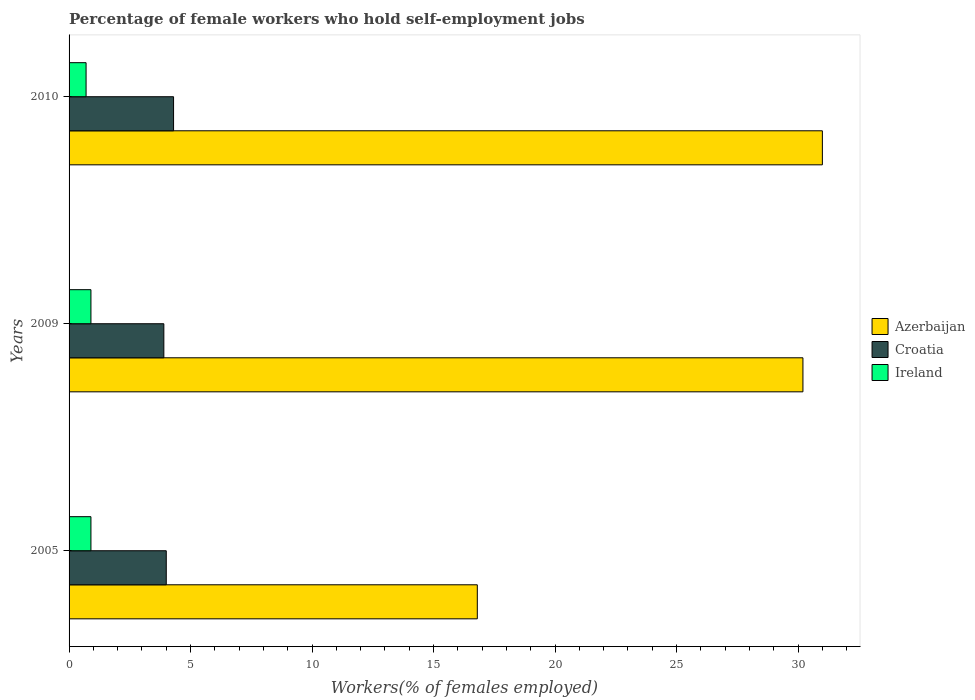How many bars are there on the 1st tick from the top?
Ensure brevity in your answer.  3. How many bars are there on the 3rd tick from the bottom?
Offer a terse response. 3. What is the label of the 1st group of bars from the top?
Give a very brief answer. 2010. What is the percentage of self-employed female workers in Azerbaijan in 2010?
Your answer should be compact. 31. Across all years, what is the maximum percentage of self-employed female workers in Croatia?
Your answer should be very brief. 4.3. Across all years, what is the minimum percentage of self-employed female workers in Croatia?
Offer a terse response. 3.9. In which year was the percentage of self-employed female workers in Ireland minimum?
Your answer should be very brief. 2010. What is the total percentage of self-employed female workers in Ireland in the graph?
Provide a succinct answer. 2.5. What is the difference between the percentage of self-employed female workers in Croatia in 2005 and that in 2009?
Your answer should be compact. 0.1. What is the difference between the percentage of self-employed female workers in Croatia in 2010 and the percentage of self-employed female workers in Ireland in 2009?
Ensure brevity in your answer.  3.4. What is the average percentage of self-employed female workers in Azerbaijan per year?
Provide a succinct answer. 26. In the year 2010, what is the difference between the percentage of self-employed female workers in Croatia and percentage of self-employed female workers in Azerbaijan?
Offer a terse response. -26.7. In how many years, is the percentage of self-employed female workers in Ireland greater than 26 %?
Make the answer very short. 0. What is the ratio of the percentage of self-employed female workers in Azerbaijan in 2009 to that in 2010?
Offer a very short reply. 0.97. Is the percentage of self-employed female workers in Azerbaijan in 2005 less than that in 2010?
Offer a terse response. Yes. What is the difference between the highest and the second highest percentage of self-employed female workers in Ireland?
Offer a very short reply. 0. What is the difference between the highest and the lowest percentage of self-employed female workers in Ireland?
Keep it short and to the point. 0.2. In how many years, is the percentage of self-employed female workers in Ireland greater than the average percentage of self-employed female workers in Ireland taken over all years?
Your response must be concise. 2. Is the sum of the percentage of self-employed female workers in Azerbaijan in 2005 and 2009 greater than the maximum percentage of self-employed female workers in Croatia across all years?
Keep it short and to the point. Yes. What does the 3rd bar from the top in 2005 represents?
Make the answer very short. Azerbaijan. What does the 2nd bar from the bottom in 2005 represents?
Make the answer very short. Croatia. Is it the case that in every year, the sum of the percentage of self-employed female workers in Azerbaijan and percentage of self-employed female workers in Ireland is greater than the percentage of self-employed female workers in Croatia?
Give a very brief answer. Yes. What is the difference between two consecutive major ticks on the X-axis?
Provide a succinct answer. 5. Does the graph contain grids?
Your response must be concise. No. How are the legend labels stacked?
Make the answer very short. Vertical. What is the title of the graph?
Give a very brief answer. Percentage of female workers who hold self-employment jobs. Does "Micronesia" appear as one of the legend labels in the graph?
Your answer should be very brief. No. What is the label or title of the X-axis?
Offer a terse response. Workers(% of females employed). What is the Workers(% of females employed) of Azerbaijan in 2005?
Make the answer very short. 16.8. What is the Workers(% of females employed) of Ireland in 2005?
Offer a terse response. 0.9. What is the Workers(% of females employed) of Azerbaijan in 2009?
Offer a very short reply. 30.2. What is the Workers(% of females employed) in Croatia in 2009?
Make the answer very short. 3.9. What is the Workers(% of females employed) of Ireland in 2009?
Your response must be concise. 0.9. What is the Workers(% of females employed) of Croatia in 2010?
Make the answer very short. 4.3. What is the Workers(% of females employed) of Ireland in 2010?
Keep it short and to the point. 0.7. Across all years, what is the maximum Workers(% of females employed) in Azerbaijan?
Your response must be concise. 31. Across all years, what is the maximum Workers(% of females employed) in Croatia?
Give a very brief answer. 4.3. Across all years, what is the maximum Workers(% of females employed) in Ireland?
Keep it short and to the point. 0.9. Across all years, what is the minimum Workers(% of females employed) in Azerbaijan?
Keep it short and to the point. 16.8. Across all years, what is the minimum Workers(% of females employed) of Croatia?
Ensure brevity in your answer.  3.9. Across all years, what is the minimum Workers(% of females employed) in Ireland?
Your response must be concise. 0.7. What is the total Workers(% of females employed) of Azerbaijan in the graph?
Make the answer very short. 78. What is the difference between the Workers(% of females employed) of Ireland in 2005 and that in 2009?
Give a very brief answer. 0. What is the difference between the Workers(% of females employed) of Croatia in 2005 and that in 2010?
Make the answer very short. -0.3. What is the difference between the Workers(% of females employed) in Ireland in 2005 and that in 2010?
Provide a succinct answer. 0.2. What is the difference between the Workers(% of females employed) in Azerbaijan in 2009 and that in 2010?
Keep it short and to the point. -0.8. What is the difference between the Workers(% of females employed) in Azerbaijan in 2005 and the Workers(% of females employed) in Croatia in 2009?
Your answer should be very brief. 12.9. What is the difference between the Workers(% of females employed) of Azerbaijan in 2005 and the Workers(% of females employed) of Ireland in 2009?
Your answer should be very brief. 15.9. What is the difference between the Workers(% of females employed) of Azerbaijan in 2005 and the Workers(% of females employed) of Croatia in 2010?
Provide a short and direct response. 12.5. What is the difference between the Workers(% of females employed) of Azerbaijan in 2005 and the Workers(% of females employed) of Ireland in 2010?
Give a very brief answer. 16.1. What is the difference between the Workers(% of females employed) of Azerbaijan in 2009 and the Workers(% of females employed) of Croatia in 2010?
Ensure brevity in your answer.  25.9. What is the difference between the Workers(% of females employed) of Azerbaijan in 2009 and the Workers(% of females employed) of Ireland in 2010?
Provide a succinct answer. 29.5. What is the difference between the Workers(% of females employed) of Croatia in 2009 and the Workers(% of females employed) of Ireland in 2010?
Give a very brief answer. 3.2. What is the average Workers(% of females employed) in Croatia per year?
Offer a very short reply. 4.07. What is the average Workers(% of females employed) in Ireland per year?
Offer a terse response. 0.83. In the year 2005, what is the difference between the Workers(% of females employed) of Azerbaijan and Workers(% of females employed) of Croatia?
Provide a short and direct response. 12.8. In the year 2005, what is the difference between the Workers(% of females employed) in Azerbaijan and Workers(% of females employed) in Ireland?
Offer a very short reply. 15.9. In the year 2005, what is the difference between the Workers(% of females employed) in Croatia and Workers(% of females employed) in Ireland?
Your answer should be very brief. 3.1. In the year 2009, what is the difference between the Workers(% of females employed) in Azerbaijan and Workers(% of females employed) in Croatia?
Make the answer very short. 26.3. In the year 2009, what is the difference between the Workers(% of females employed) of Azerbaijan and Workers(% of females employed) of Ireland?
Provide a succinct answer. 29.3. In the year 2010, what is the difference between the Workers(% of females employed) of Azerbaijan and Workers(% of females employed) of Croatia?
Provide a short and direct response. 26.7. In the year 2010, what is the difference between the Workers(% of females employed) in Azerbaijan and Workers(% of females employed) in Ireland?
Make the answer very short. 30.3. In the year 2010, what is the difference between the Workers(% of females employed) in Croatia and Workers(% of females employed) in Ireland?
Your answer should be compact. 3.6. What is the ratio of the Workers(% of females employed) in Azerbaijan in 2005 to that in 2009?
Offer a terse response. 0.56. What is the ratio of the Workers(% of females employed) of Croatia in 2005 to that in 2009?
Give a very brief answer. 1.03. What is the ratio of the Workers(% of females employed) in Ireland in 2005 to that in 2009?
Provide a short and direct response. 1. What is the ratio of the Workers(% of females employed) of Azerbaijan in 2005 to that in 2010?
Give a very brief answer. 0.54. What is the ratio of the Workers(% of females employed) of Croatia in 2005 to that in 2010?
Offer a terse response. 0.93. What is the ratio of the Workers(% of females employed) of Azerbaijan in 2009 to that in 2010?
Your answer should be very brief. 0.97. What is the ratio of the Workers(% of females employed) in Croatia in 2009 to that in 2010?
Offer a terse response. 0.91. What is the ratio of the Workers(% of females employed) of Ireland in 2009 to that in 2010?
Offer a very short reply. 1.29. What is the difference between the highest and the second highest Workers(% of females employed) of Croatia?
Your answer should be compact. 0.3. What is the difference between the highest and the lowest Workers(% of females employed) of Azerbaijan?
Provide a short and direct response. 14.2. What is the difference between the highest and the lowest Workers(% of females employed) in Croatia?
Offer a terse response. 0.4. What is the difference between the highest and the lowest Workers(% of females employed) of Ireland?
Offer a terse response. 0.2. 